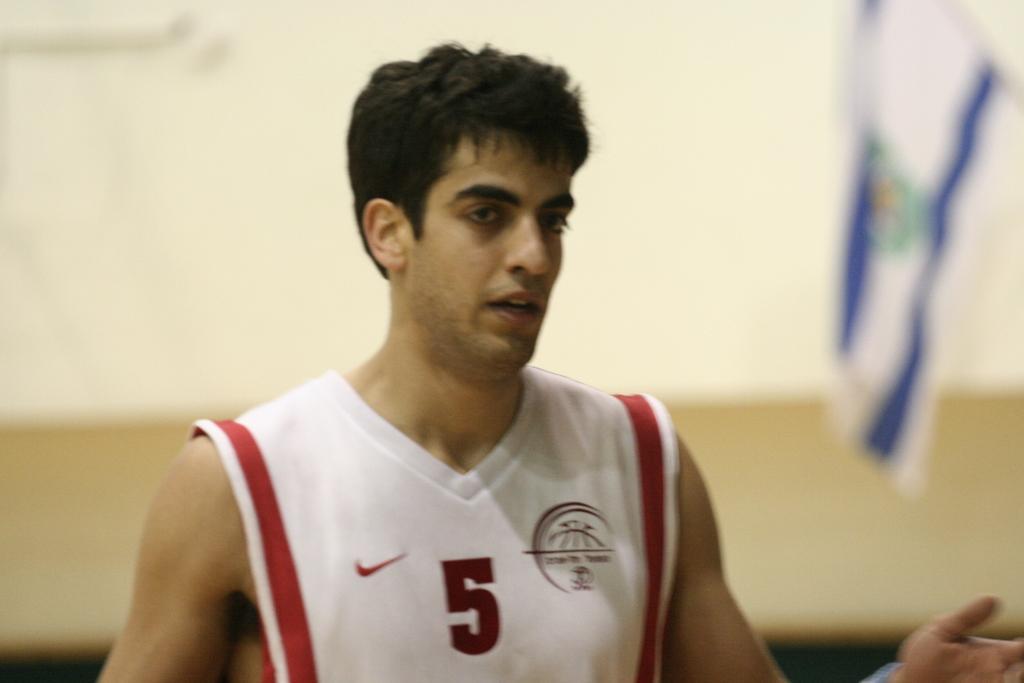In one or two sentences, can you explain what this image depicts? In the middle of the image, there is a person in white color t-shirt. In the background, there is a flag. And the background is blurred. 